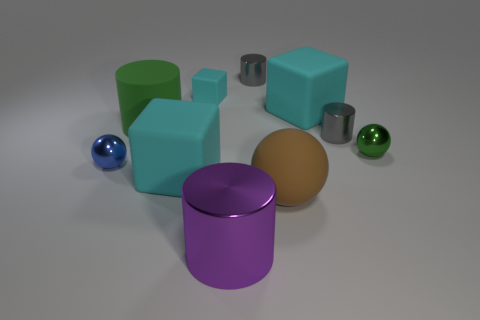Subtract all spheres. How many objects are left? 7 Subtract all large cubes. How many cubes are left? 1 Subtract 2 cylinders. How many cylinders are left? 2 Subtract all yellow blocks. Subtract all red cylinders. How many blocks are left? 3 Subtract all red cubes. How many brown spheres are left? 1 Subtract all small shiny spheres. Subtract all big brown things. How many objects are left? 7 Add 6 shiny cylinders. How many shiny cylinders are left? 9 Add 4 large yellow shiny cylinders. How many large yellow shiny cylinders exist? 4 Subtract all purple cylinders. How many cylinders are left? 3 Subtract 0 yellow spheres. How many objects are left? 10 